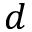Convert formula to latex. <formula><loc_0><loc_0><loc_500><loc_500>d</formula> 